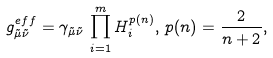Convert formula to latex. <formula><loc_0><loc_0><loc_500><loc_500>g _ { { \tilde { \mu } } \tilde { \nu } } ^ { e f f } = \gamma _ { { \tilde { \mu } } \tilde { \nu } } \, \prod _ { i = 1 } ^ { m } H _ { i } ^ { p ( n ) } , \, p ( n ) = \frac { 2 } { n + 2 } ,</formula> 